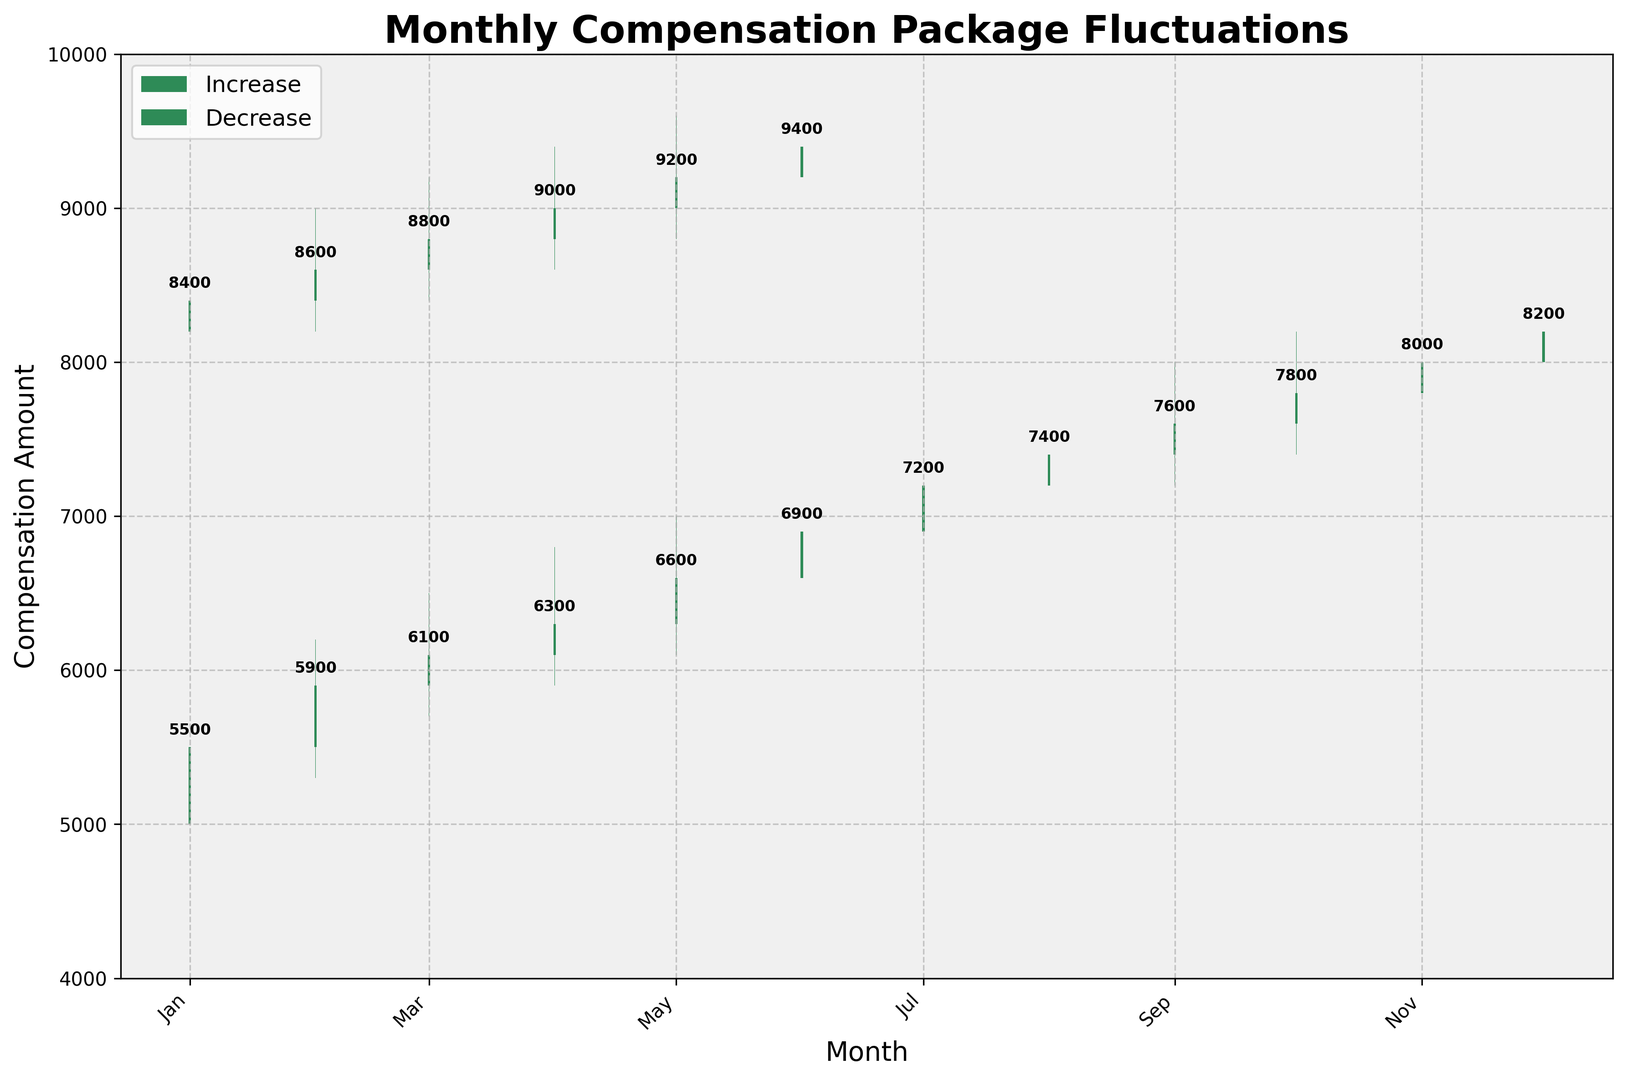What is the highest recorded compensation amount in the data? Look at the highest points of the bars representing the "High" values; the maximum value is 9800, recorded in June.
Answer: 9800 Which month had the largest increase in the compensation package? Identify the bars where the difference between "Close" and "Open" is the largest; August had the largest increase from 7200 to 7800, a difference of 600.
Answer: August What is the lowest closing compensation amount in the data? Assess all the closing values on the chart; the lowest closing value is 5500, recorded in January.
Answer: 5500 Which month had the highest fluctuation between the highest and lowest compensation amounts? Calculate the difference between "High" and "Low" for each month, and April had the highest fluctuation from 9400 to 8600, a difference of 800.
Answer: April What's the average compensation closing value over the entire period? Sum all the closing values and divide by the number of data points; total sum is 161000 over 18 months, so the average is 161000/18 = 8944.
Answer: 8944 Did May's compensation package increase or decrease, and by how much? Check May's "Open" and "Close" values; in May, the compensation increased from 9000 to 9200, an increase of 200.
Answer: Increase by 200 Which month had consecutive increases in the compensation package closing value? Review the closing values month by month and look for an upward trend over multiple months; the three months from April to June show consecutive increases.
Answer: April to June Between January and December, by how much did the compensation package close increase? Compare the closing value of January and December; January closed at 5500, and December at 8200, resulting in a difference of 2700.
Answer: 2700 What is the average increase in closing values from one month to the next over the entire period? Compute the monthly differences in closing values, average those differences; total increase is (5500-5500) + (5900-5500) + ... + (9400-9200) = 8400 over 17 intervals, so the average is 8400/17 ≈ 494.
Answer: 494 Which months had the closing compensation amounts exactly at 8000 or higher? Identify any month(s) where the closing value is 8000 or higher; November, December, January, February, March, April, May, June.
Answer: November, December, January, February, March, April, May, June 